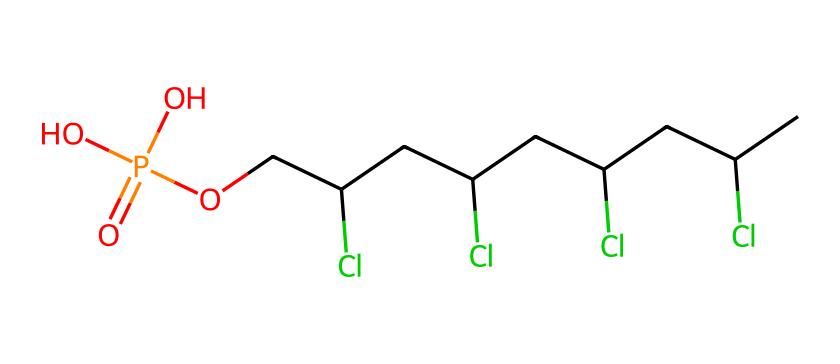what is the total number of chlorine atoms in this compound? By examining the SMILES representation, we can count the number of occurrences of "Cl." In the provided structure, "CC(Cl)" appears four times, indicating there are four chlorine atoms.
Answer: 4 how many carbon atoms are present in this molecule? The SMILES structure displays a series of "C" letters which represent carbon atoms. Counting all the "C" in the representation, we find a total of 8 carbon atoms in the chain.
Answer: 8 what is the functional group present in this compound? The phosphorus atom is connected to oxygen atoms in a manner typical of phosphate groups. The presence of "COP(=O)(O)O" indicates that this chemical includes a phosphate functional group.
Answer: phosphate does this molecule contain any nitrogen atoms? By inspecting the SMILES string, there are no occurrences of "N," which indicates that this molecule does not include nitrogen atoms.
Answer: no which part of the molecule is responsible for flame retardancy? The presence of chlorine atoms can significantly contribute to flame retardancy due to their ability to disrupt flame propagation. They can effectively reduce flammability and increase the thermal stability of materials.
Answer: chlorine atoms what type of compound is represented by the chemical structure? Given the presence of multiple chlorine atoms and a phosphate group, this compound falls under the classification of flame-retardant polymers suitable for use in wiring insulation.
Answer: flame-retardant polymer 